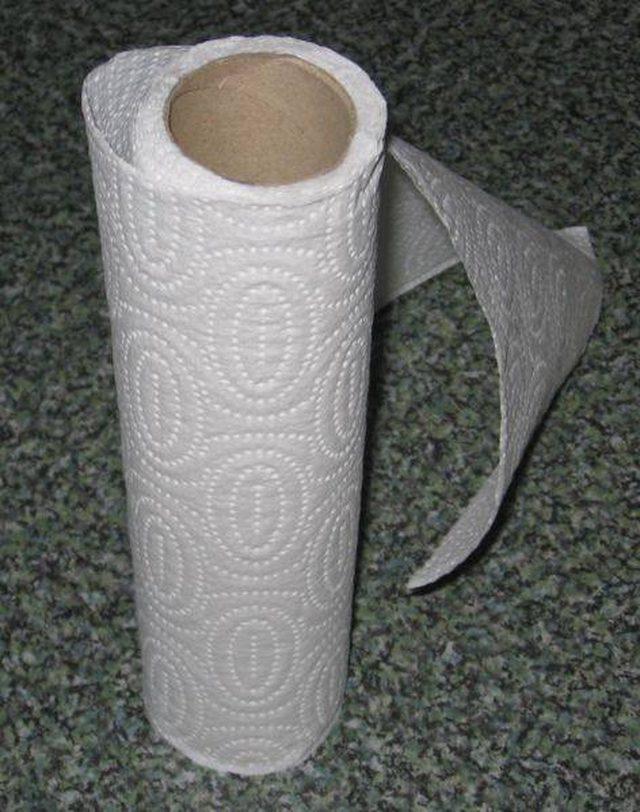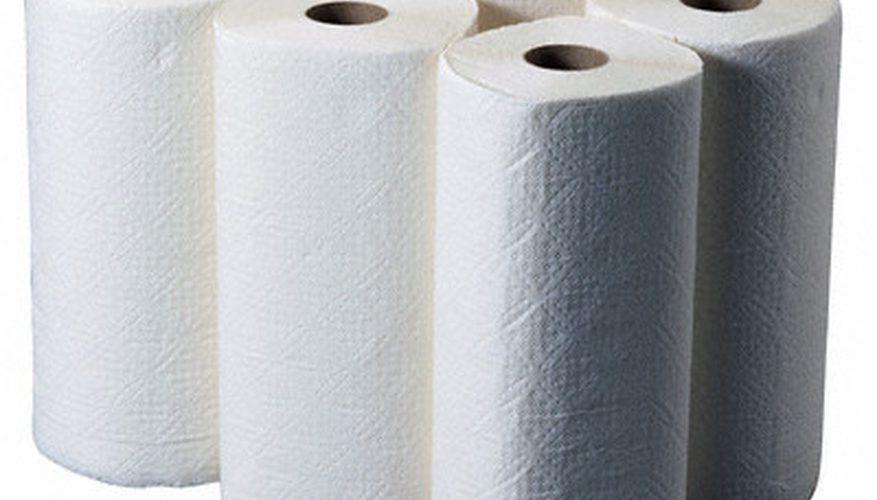The first image is the image on the left, the second image is the image on the right. Considering the images on both sides, is "An image shows a single white roll on a wood surface." valid? Answer yes or no. No. 